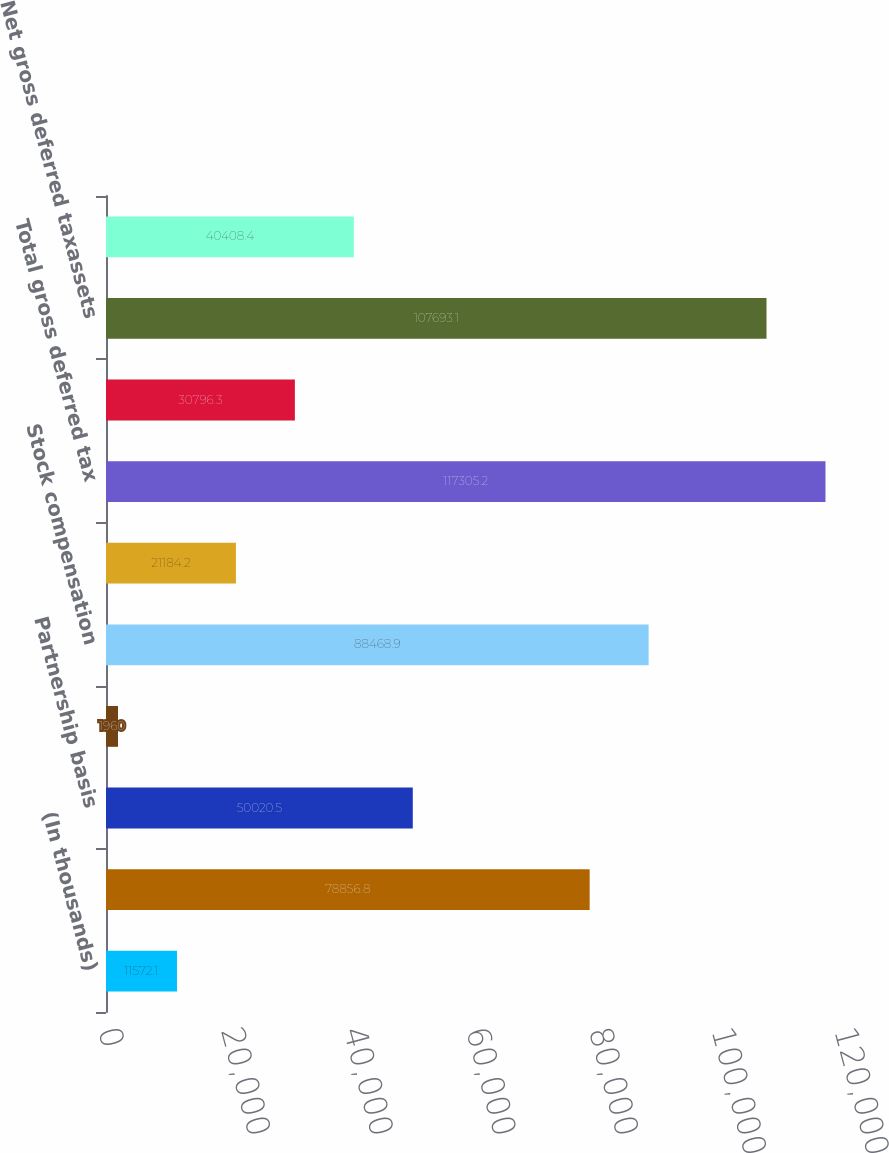<chart> <loc_0><loc_0><loc_500><loc_500><bar_chart><fcel>(In thousands)<fcel>Accrued expenses<fcel>Partnership basis<fcel>Inventory<fcel>Stock compensation<fcel>Capital loss carry forward<fcel>Total gross deferred tax<fcel>Less valuation allowance<fcel>Net gross deferred taxassets<fcel>Prepaid expenses<nl><fcel>11572.1<fcel>78856.8<fcel>50020.5<fcel>1960<fcel>88468.9<fcel>21184.2<fcel>117305<fcel>30796.3<fcel>107693<fcel>40408.4<nl></chart> 